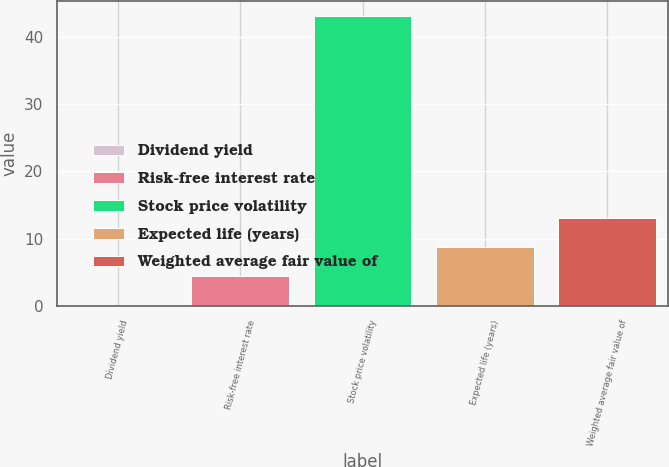Convert chart. <chart><loc_0><loc_0><loc_500><loc_500><bar_chart><fcel>Dividend yield<fcel>Risk-free interest rate<fcel>Stock price volatility<fcel>Expected life (years)<fcel>Weighted average fair value of<nl><fcel>0.13<fcel>4.43<fcel>43.1<fcel>8.73<fcel>13.03<nl></chart> 